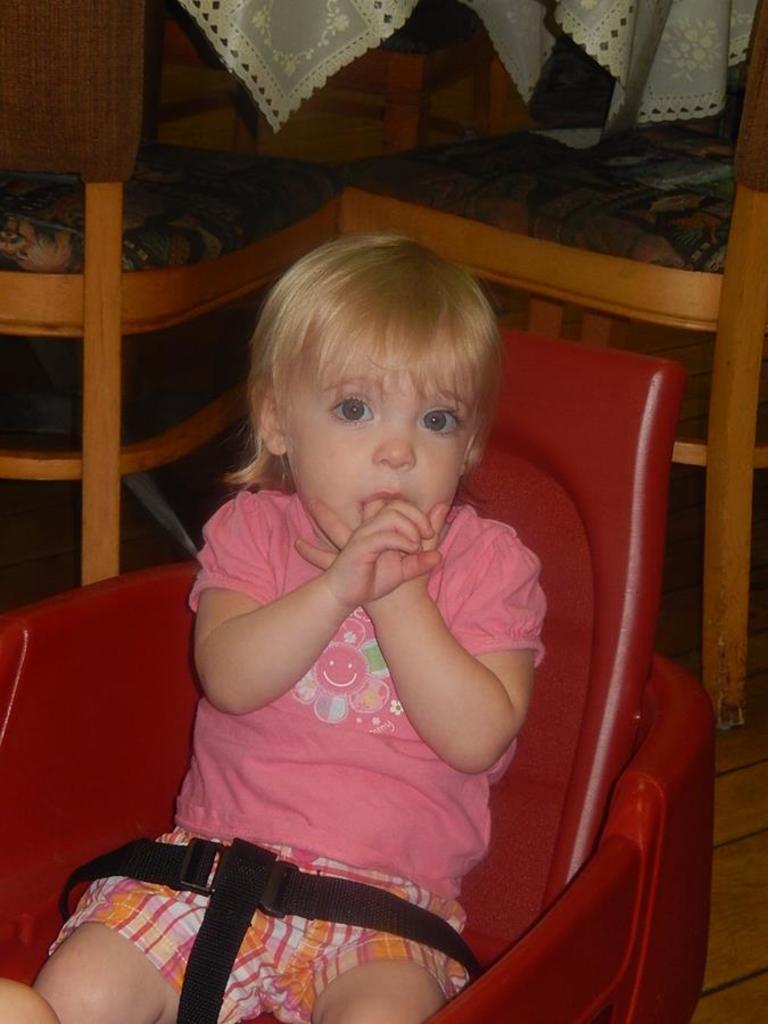In one or two sentences, can you explain what this image depicts? In the center we can see baby sitting on the chair. Coming to the background we can see two more chairs and cloth. 